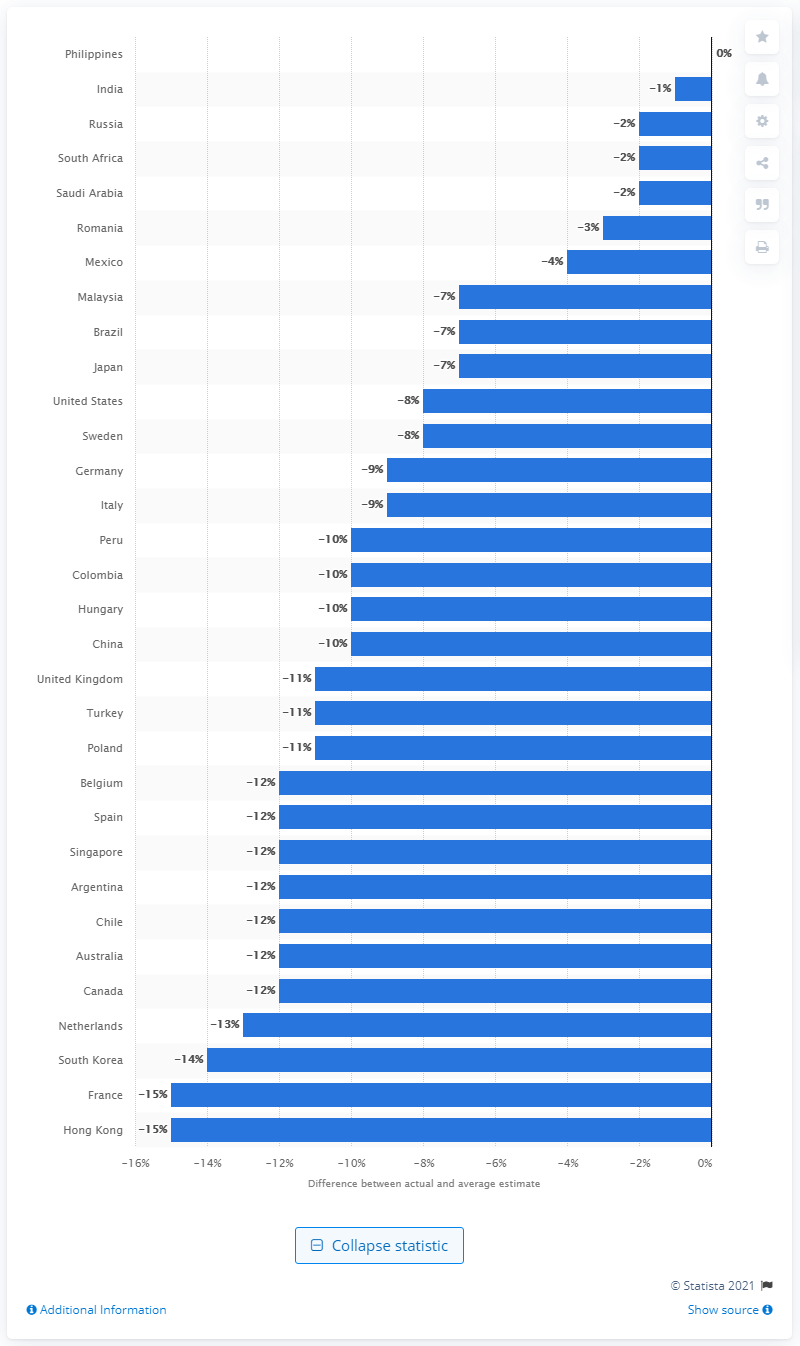Indicate a few pertinent items in this graphic. The country most likely to correctly estimate the percentage of deaths caused by cancer in their country was the Philippines. 